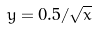<formula> <loc_0><loc_0><loc_500><loc_500>y = 0 . 5 / \sqrt { x }</formula> 